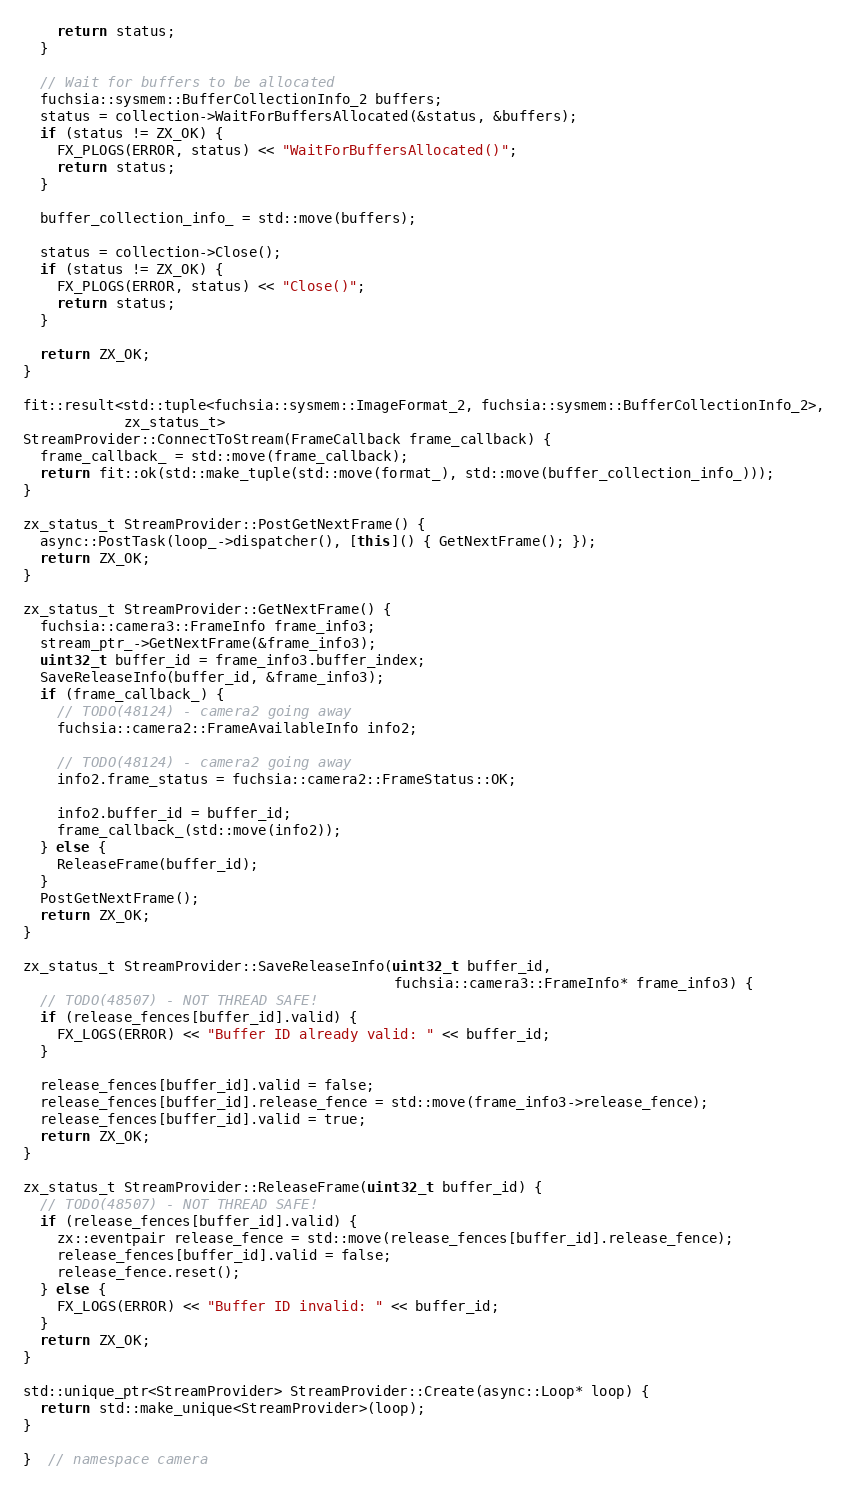<code> <loc_0><loc_0><loc_500><loc_500><_C++_>    return status;
  }

  // Wait for buffers to be allocated
  fuchsia::sysmem::BufferCollectionInfo_2 buffers;
  status = collection->WaitForBuffersAllocated(&status, &buffers);
  if (status != ZX_OK) {
    FX_PLOGS(ERROR, status) << "WaitForBuffersAllocated()";
    return status;
  }

  buffer_collection_info_ = std::move(buffers);

  status = collection->Close();
  if (status != ZX_OK) {
    FX_PLOGS(ERROR, status) << "Close()";
    return status;
  }

  return ZX_OK;
}

fit::result<std::tuple<fuchsia::sysmem::ImageFormat_2, fuchsia::sysmem::BufferCollectionInfo_2>,
            zx_status_t>
StreamProvider::ConnectToStream(FrameCallback frame_callback) {
  frame_callback_ = std::move(frame_callback);
  return fit::ok(std::make_tuple(std::move(format_), std::move(buffer_collection_info_)));
}

zx_status_t StreamProvider::PostGetNextFrame() {
  async::PostTask(loop_->dispatcher(), [this]() { GetNextFrame(); });
  return ZX_OK;
}

zx_status_t StreamProvider::GetNextFrame() {
  fuchsia::camera3::FrameInfo frame_info3;
  stream_ptr_->GetNextFrame(&frame_info3);
  uint32_t buffer_id = frame_info3.buffer_index;
  SaveReleaseInfo(buffer_id, &frame_info3);
  if (frame_callback_) {
    // TODO(48124) - camera2 going away
    fuchsia::camera2::FrameAvailableInfo info2;

    // TODO(48124) - camera2 going away
    info2.frame_status = fuchsia::camera2::FrameStatus::OK;

    info2.buffer_id = buffer_id;
    frame_callback_(std::move(info2));
  } else {
    ReleaseFrame(buffer_id);
  }
  PostGetNextFrame();
  return ZX_OK;
}

zx_status_t StreamProvider::SaveReleaseInfo(uint32_t buffer_id,
                                            fuchsia::camera3::FrameInfo* frame_info3) {
  // TODO(48507) - NOT THREAD SAFE!
  if (release_fences[buffer_id].valid) {
    FX_LOGS(ERROR) << "Buffer ID already valid: " << buffer_id;
  }

  release_fences[buffer_id].valid = false;
  release_fences[buffer_id].release_fence = std::move(frame_info3->release_fence);
  release_fences[buffer_id].valid = true;
  return ZX_OK;
}

zx_status_t StreamProvider::ReleaseFrame(uint32_t buffer_id) {
  // TODO(48507) - NOT THREAD SAFE!
  if (release_fences[buffer_id].valid) {
    zx::eventpair release_fence = std::move(release_fences[buffer_id].release_fence);
    release_fences[buffer_id].valid = false;
    release_fence.reset();
  } else {
    FX_LOGS(ERROR) << "Buffer ID invalid: " << buffer_id;
  }
  return ZX_OK;
}

std::unique_ptr<StreamProvider> StreamProvider::Create(async::Loop* loop) {
  return std::make_unique<StreamProvider>(loop);
}

}  // namespace camera
</code> 